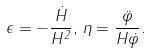Convert formula to latex. <formula><loc_0><loc_0><loc_500><loc_500>\epsilon = - \frac { \dot { H } } { H ^ { 2 } } , \, \eta = \frac { \ddot { \varphi } } { H \dot { \varphi } } .</formula> 